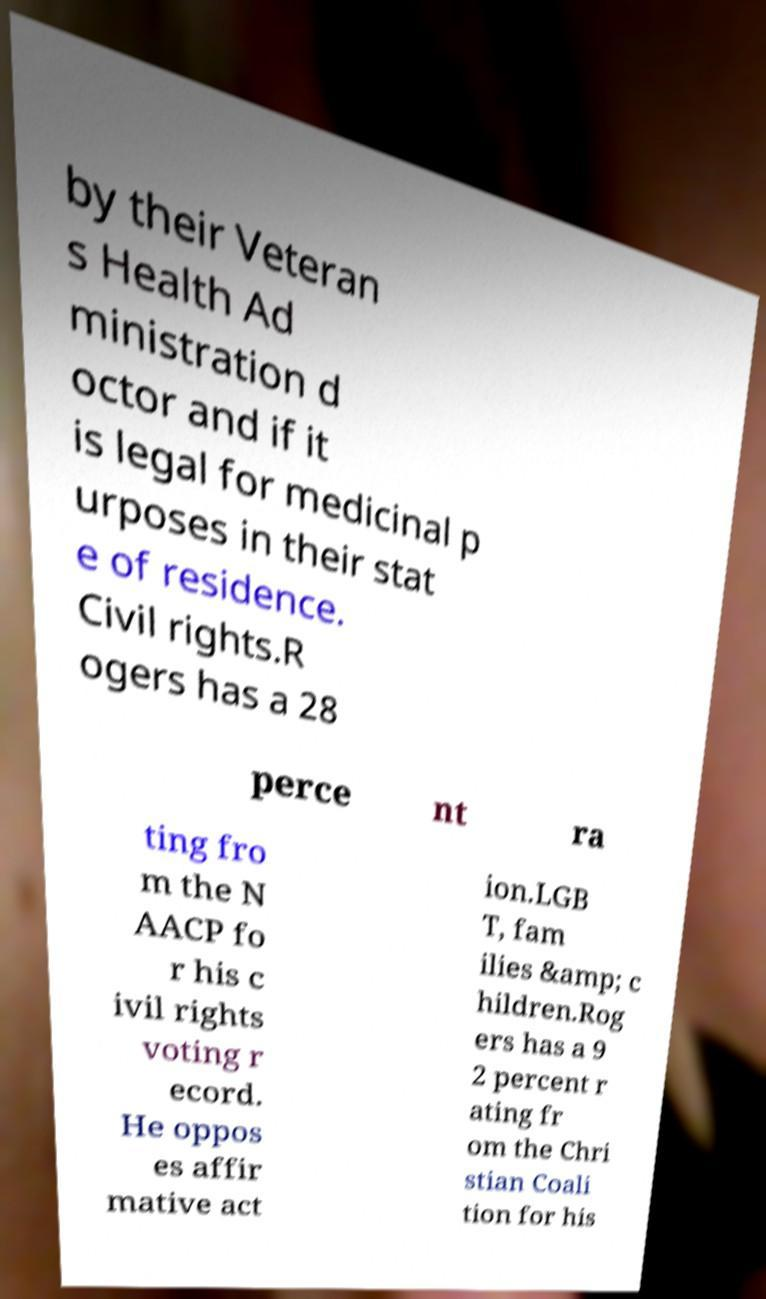Could you extract and type out the text from this image? by their Veteran s Health Ad ministration d octor and if it is legal for medicinal p urposes in their stat e of residence. Civil rights.R ogers has a 28 perce nt ra ting fro m the N AACP fo r his c ivil rights voting r ecord. He oppos es affir mative act ion.LGB T, fam ilies &amp; c hildren.Rog ers has a 9 2 percent r ating fr om the Chri stian Coali tion for his 